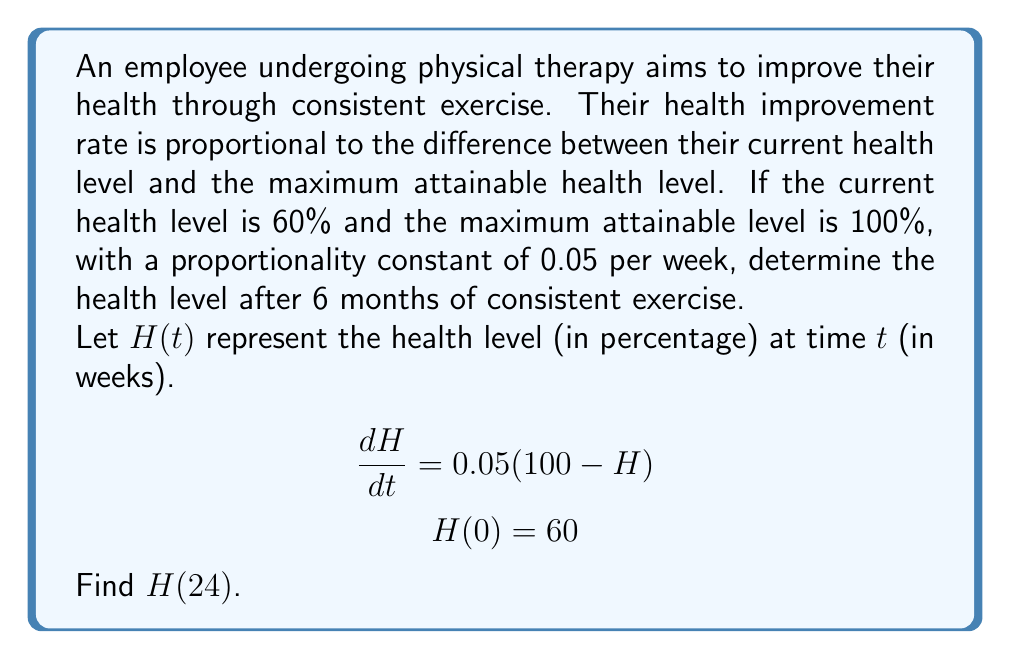Can you answer this question? To solve this first-order differential equation:

1) The general solution for this type of equation is:
   $$H(t) = 100 - (100 - H_0)e^{-kt}$$
   where $H_0$ is the initial health level and $k$ is the proportionality constant.

2) Substitute the given values:
   $H_0 = 60$, $k = 0.05$

3) The specific solution becomes:
   $$H(t) = 100 - (100 - 60)e^{-0.05t}$$
   $$H(t) = 100 - 40e^{-0.05t}$$

4) To find the health level after 6 months (24 weeks), calculate $H(24)$:
   $$H(24) = 100 - 40e^{-0.05(24)}$$
   $$H(24) = 100 - 40e^{-1.2}$$
   $$H(24) = 100 - 40(0.301194...)$$
   $$H(24) = 100 - 12.04776...$$
   $$H(24) \approx 87.95\%$$

5) Round to two decimal places for the final answer.
Answer: 87.95% 